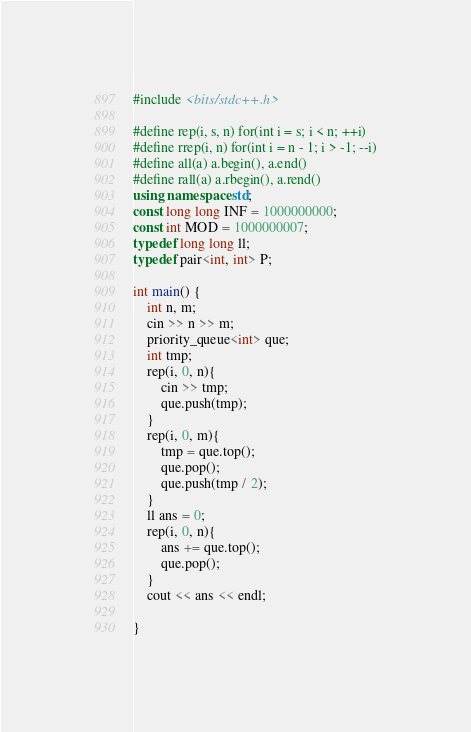<code> <loc_0><loc_0><loc_500><loc_500><_C++_>#include <bits/stdc++.h>

#define rep(i, s, n) for(int i = s; i < n; ++i)
#define rrep(i, n) for(int i = n - 1; i > -1; --i)
#define all(a) a.begin(), a.end()
#define rall(a) a.rbegin(), a.rend()
using namespace std;
const long long INF = 1000000000;
const int MOD = 1000000007;
typedef long long ll;
typedef pair<int, int> P;

int main() {
    int n, m;
    cin >> n >> m;
    priority_queue<int> que;
    int tmp;
    rep(i, 0, n){
        cin >> tmp;
        que.push(tmp);
    }
    rep(i, 0, m){
        tmp = que.top();
        que.pop();
        que.push(tmp / 2);
    }
    ll ans = 0;
    rep(i, 0, n){
        ans += que.top();
        que.pop();
    }
    cout << ans << endl;

}
</code> 